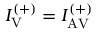Convert formula to latex. <formula><loc_0><loc_0><loc_500><loc_500>I _ { V } ^ { ( + ) } = I _ { A V } ^ { ( + ) }</formula> 